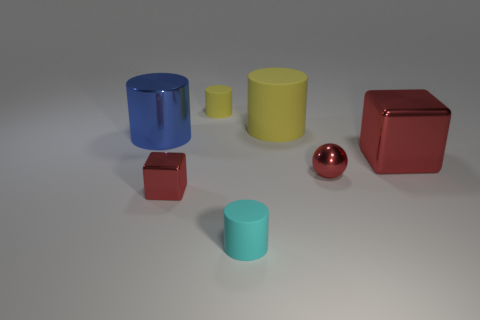Subtract all tiny yellow cylinders. How many cylinders are left? 3 Add 2 large cylinders. How many objects exist? 9 Subtract all cyan cylinders. How many cylinders are left? 3 Subtract all cylinders. How many objects are left? 3 Subtract 1 balls. How many balls are left? 0 Subtract all yellow spheres. Subtract all purple cylinders. How many spheres are left? 1 Subtract all gray cylinders. How many cyan spheres are left? 0 Subtract all yellow metal cylinders. Subtract all small spheres. How many objects are left? 6 Add 2 tiny red metallic blocks. How many tiny red metallic blocks are left? 3 Add 4 large green cylinders. How many large green cylinders exist? 4 